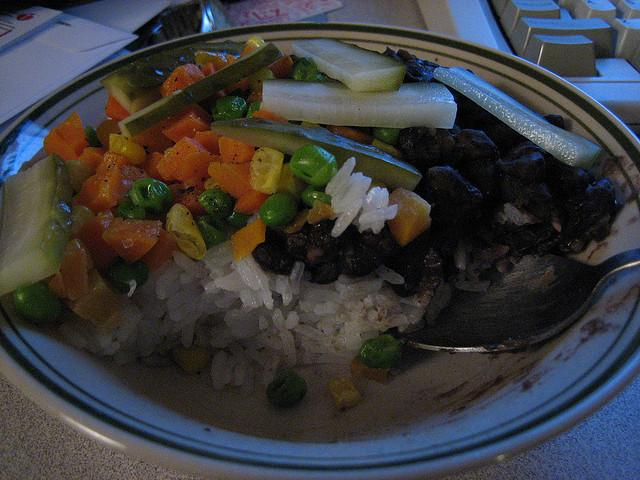What is available on this meal among the following ingredients options?

Choices:
A) rice
B) beans
C) broccoli
D) kale rice 